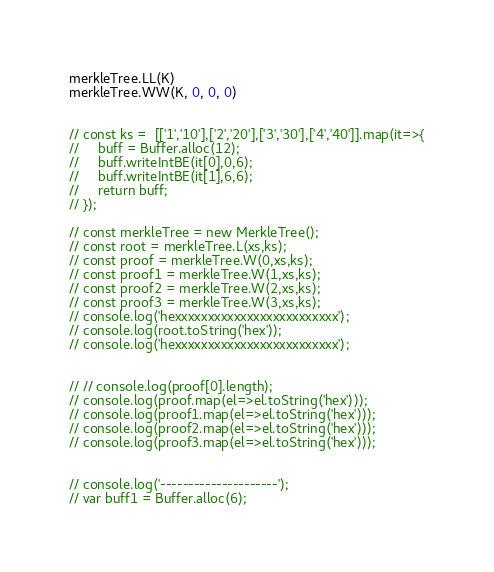Convert code to text. <code><loc_0><loc_0><loc_500><loc_500><_JavaScript_>merkleTree.LL(K)
merkleTree.WW(K, 0, 0, 0)


// const ks =  [['1','10'],['2','20'],['3','30'],['4','40']].map(it=>{
//     buff = Buffer.alloc(12);
//     buff.writeIntBE(it[0],0,6);
//     buff.writeIntBE(it[1],6,6);
//     return buff;
// });

// const merkleTree = new MerkleTree();
// const root = merkleTree.L(xs,ks);
// const proof = merkleTree.W(0,xs,ks);
// const proof1 = merkleTree.W(1,xs,ks);
// const proof2 = merkleTree.W(2,xs,ks);
// const proof3 = merkleTree.W(3,xs,ks);
// console.log('hexxxxxxxxxxxxxxxxxxxxxxxxx');
// console.log(root.toString('hex'));
// console.log('hexxxxxxxxxxxxxxxxxxxxxxxxx');


// // console.log(proof[0].length);
// console.log(proof.map(el=>el.toString('hex')));
// console.log(proof1.map(el=>el.toString('hex')));
// console.log(proof2.map(el=>el.toString('hex')));
// console.log(proof3.map(el=>el.toString('hex')));


// console.log('---------------------');
// var buff1 = Buffer.alloc(6);</code> 